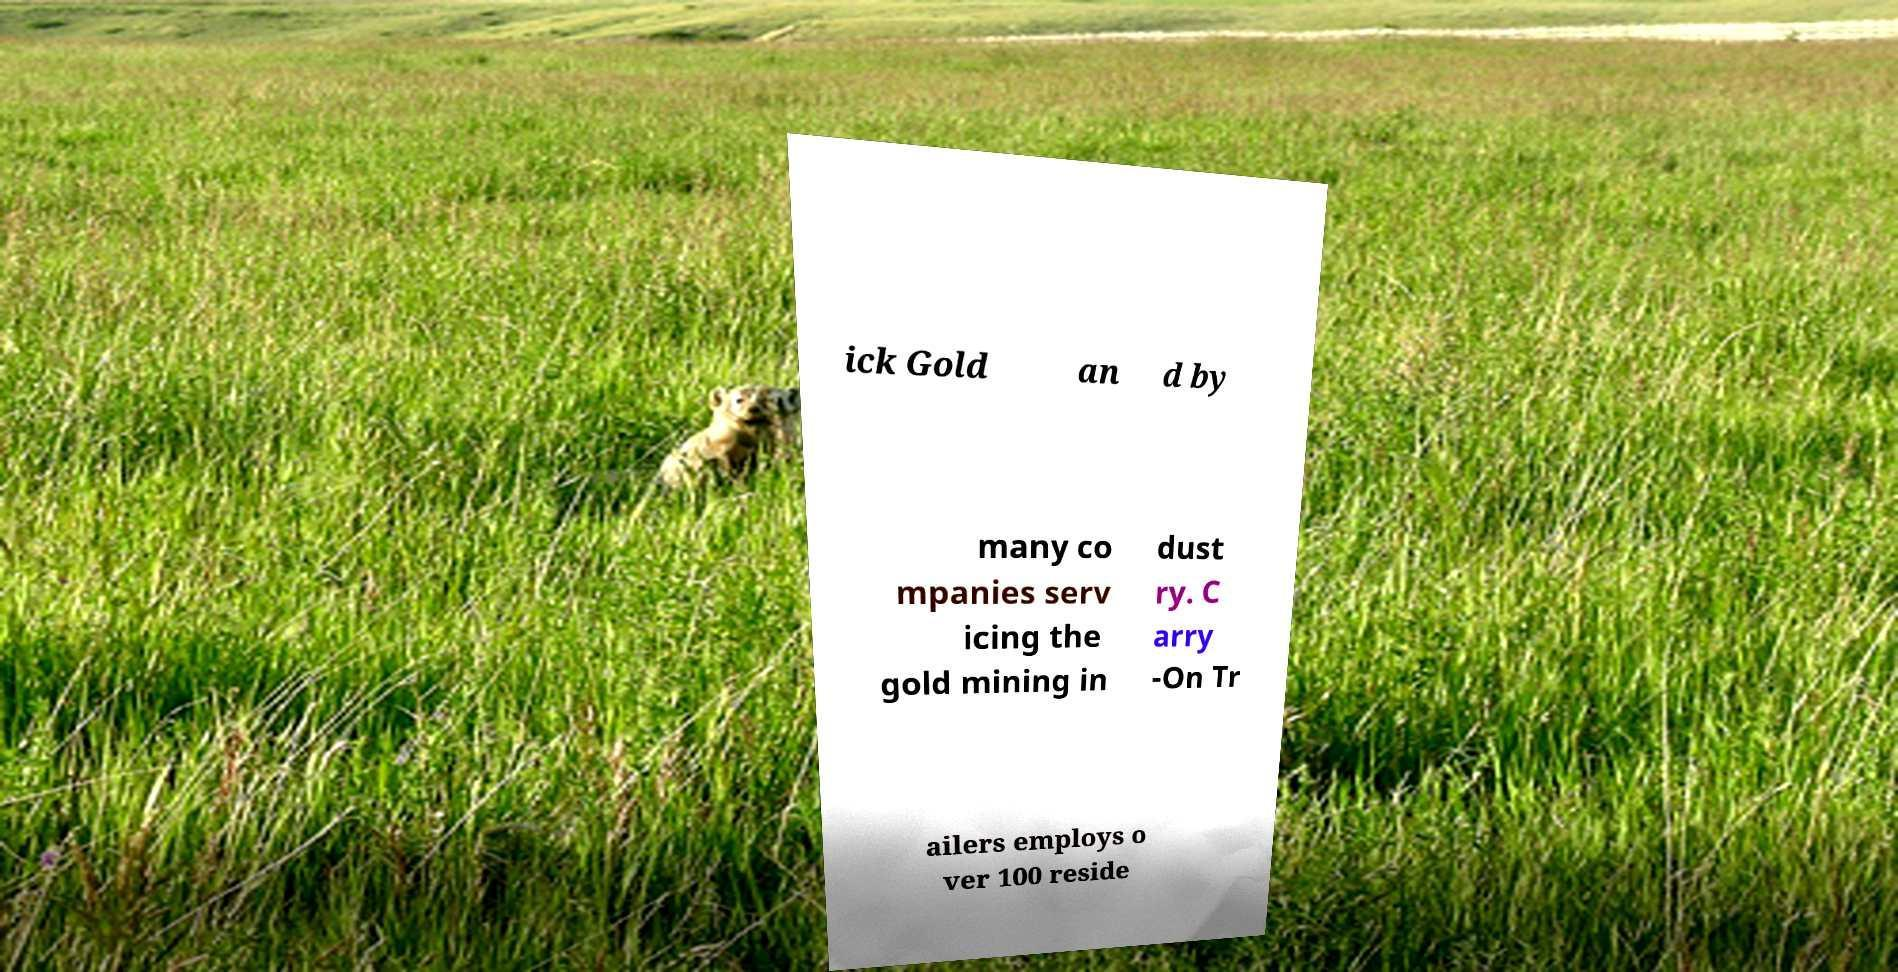Please read and relay the text visible in this image. What does it say? ick Gold an d by many co mpanies serv icing the gold mining in dust ry. C arry -On Tr ailers employs o ver 100 reside 